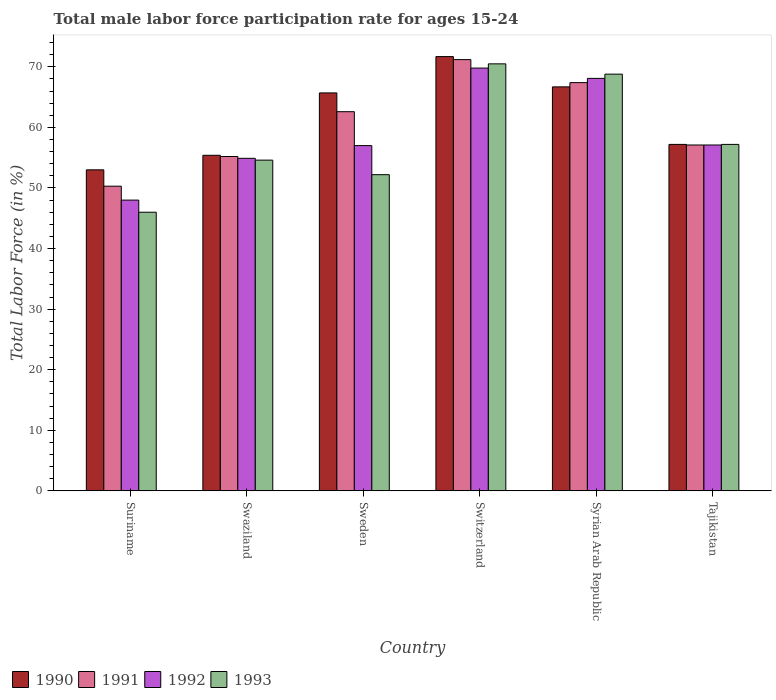How many groups of bars are there?
Offer a terse response. 6. Are the number of bars on each tick of the X-axis equal?
Make the answer very short. Yes. How many bars are there on the 5th tick from the left?
Give a very brief answer. 4. How many bars are there on the 3rd tick from the right?
Your response must be concise. 4. What is the label of the 2nd group of bars from the left?
Offer a terse response. Swaziland. What is the male labor force participation rate in 1993 in Switzerland?
Make the answer very short. 70.5. Across all countries, what is the maximum male labor force participation rate in 1993?
Your answer should be compact. 70.5. In which country was the male labor force participation rate in 1993 maximum?
Make the answer very short. Switzerland. In which country was the male labor force participation rate in 1992 minimum?
Your answer should be very brief. Suriname. What is the total male labor force participation rate in 1993 in the graph?
Give a very brief answer. 349.3. What is the difference between the male labor force participation rate in 1992 in Switzerland and that in Syrian Arab Republic?
Offer a very short reply. 1.7. What is the difference between the male labor force participation rate in 1990 in Sweden and the male labor force participation rate in 1993 in Syrian Arab Republic?
Your answer should be very brief. -3.1. What is the average male labor force participation rate in 1990 per country?
Provide a succinct answer. 61.62. What is the difference between the male labor force participation rate of/in 1993 and male labor force participation rate of/in 1992 in Sweden?
Provide a short and direct response. -4.8. What is the ratio of the male labor force participation rate in 1992 in Suriname to that in Tajikistan?
Your answer should be very brief. 0.84. What is the difference between the highest and the second highest male labor force participation rate in 1993?
Your response must be concise. -11.6. In how many countries, is the male labor force participation rate in 1993 greater than the average male labor force participation rate in 1993 taken over all countries?
Ensure brevity in your answer.  2. What does the 2nd bar from the left in Syrian Arab Republic represents?
Keep it short and to the point. 1991. Are all the bars in the graph horizontal?
Your answer should be very brief. No. What is the difference between two consecutive major ticks on the Y-axis?
Give a very brief answer. 10. Where does the legend appear in the graph?
Your answer should be compact. Bottom left. How many legend labels are there?
Give a very brief answer. 4. What is the title of the graph?
Keep it short and to the point. Total male labor force participation rate for ages 15-24. Does "1993" appear as one of the legend labels in the graph?
Make the answer very short. Yes. What is the Total Labor Force (in %) of 1991 in Suriname?
Ensure brevity in your answer.  50.3. What is the Total Labor Force (in %) of 1992 in Suriname?
Provide a succinct answer. 48. What is the Total Labor Force (in %) in 1993 in Suriname?
Give a very brief answer. 46. What is the Total Labor Force (in %) in 1990 in Swaziland?
Give a very brief answer. 55.4. What is the Total Labor Force (in %) of 1991 in Swaziland?
Give a very brief answer. 55.2. What is the Total Labor Force (in %) of 1992 in Swaziland?
Your answer should be very brief. 54.9. What is the Total Labor Force (in %) in 1993 in Swaziland?
Your answer should be compact. 54.6. What is the Total Labor Force (in %) of 1990 in Sweden?
Provide a short and direct response. 65.7. What is the Total Labor Force (in %) of 1991 in Sweden?
Provide a succinct answer. 62.6. What is the Total Labor Force (in %) of 1992 in Sweden?
Your response must be concise. 57. What is the Total Labor Force (in %) in 1993 in Sweden?
Keep it short and to the point. 52.2. What is the Total Labor Force (in %) of 1990 in Switzerland?
Your answer should be very brief. 71.7. What is the Total Labor Force (in %) in 1991 in Switzerland?
Offer a terse response. 71.2. What is the Total Labor Force (in %) in 1992 in Switzerland?
Keep it short and to the point. 69.8. What is the Total Labor Force (in %) in 1993 in Switzerland?
Provide a short and direct response. 70.5. What is the Total Labor Force (in %) of 1990 in Syrian Arab Republic?
Your response must be concise. 66.7. What is the Total Labor Force (in %) of 1991 in Syrian Arab Republic?
Your response must be concise. 67.4. What is the Total Labor Force (in %) of 1992 in Syrian Arab Republic?
Your answer should be very brief. 68.1. What is the Total Labor Force (in %) in 1993 in Syrian Arab Republic?
Give a very brief answer. 68.8. What is the Total Labor Force (in %) in 1990 in Tajikistan?
Provide a short and direct response. 57.2. What is the Total Labor Force (in %) of 1991 in Tajikistan?
Provide a short and direct response. 57.1. What is the Total Labor Force (in %) in 1992 in Tajikistan?
Ensure brevity in your answer.  57.1. What is the Total Labor Force (in %) of 1993 in Tajikistan?
Give a very brief answer. 57.2. Across all countries, what is the maximum Total Labor Force (in %) in 1990?
Keep it short and to the point. 71.7. Across all countries, what is the maximum Total Labor Force (in %) in 1991?
Ensure brevity in your answer.  71.2. Across all countries, what is the maximum Total Labor Force (in %) of 1992?
Your answer should be very brief. 69.8. Across all countries, what is the maximum Total Labor Force (in %) of 1993?
Provide a short and direct response. 70.5. Across all countries, what is the minimum Total Labor Force (in %) in 1990?
Make the answer very short. 53. Across all countries, what is the minimum Total Labor Force (in %) of 1991?
Ensure brevity in your answer.  50.3. What is the total Total Labor Force (in %) in 1990 in the graph?
Give a very brief answer. 369.7. What is the total Total Labor Force (in %) in 1991 in the graph?
Ensure brevity in your answer.  363.8. What is the total Total Labor Force (in %) in 1992 in the graph?
Your answer should be very brief. 354.9. What is the total Total Labor Force (in %) in 1993 in the graph?
Offer a terse response. 349.3. What is the difference between the Total Labor Force (in %) of 1991 in Suriname and that in Swaziland?
Provide a succinct answer. -4.9. What is the difference between the Total Labor Force (in %) of 1990 in Suriname and that in Sweden?
Keep it short and to the point. -12.7. What is the difference between the Total Labor Force (in %) in 1992 in Suriname and that in Sweden?
Provide a succinct answer. -9. What is the difference between the Total Labor Force (in %) in 1993 in Suriname and that in Sweden?
Make the answer very short. -6.2. What is the difference between the Total Labor Force (in %) in 1990 in Suriname and that in Switzerland?
Your answer should be compact. -18.7. What is the difference between the Total Labor Force (in %) in 1991 in Suriname and that in Switzerland?
Offer a very short reply. -20.9. What is the difference between the Total Labor Force (in %) of 1992 in Suriname and that in Switzerland?
Offer a very short reply. -21.8. What is the difference between the Total Labor Force (in %) in 1993 in Suriname and that in Switzerland?
Your response must be concise. -24.5. What is the difference between the Total Labor Force (in %) in 1990 in Suriname and that in Syrian Arab Republic?
Provide a succinct answer. -13.7. What is the difference between the Total Labor Force (in %) in 1991 in Suriname and that in Syrian Arab Republic?
Your answer should be compact. -17.1. What is the difference between the Total Labor Force (in %) of 1992 in Suriname and that in Syrian Arab Republic?
Keep it short and to the point. -20.1. What is the difference between the Total Labor Force (in %) in 1993 in Suriname and that in Syrian Arab Republic?
Your response must be concise. -22.8. What is the difference between the Total Labor Force (in %) in 1991 in Suriname and that in Tajikistan?
Offer a terse response. -6.8. What is the difference between the Total Labor Force (in %) in 1993 in Suriname and that in Tajikistan?
Provide a succinct answer. -11.2. What is the difference between the Total Labor Force (in %) in 1990 in Swaziland and that in Sweden?
Provide a short and direct response. -10.3. What is the difference between the Total Labor Force (in %) of 1992 in Swaziland and that in Sweden?
Offer a very short reply. -2.1. What is the difference between the Total Labor Force (in %) of 1993 in Swaziland and that in Sweden?
Give a very brief answer. 2.4. What is the difference between the Total Labor Force (in %) of 1990 in Swaziland and that in Switzerland?
Provide a short and direct response. -16.3. What is the difference between the Total Labor Force (in %) of 1992 in Swaziland and that in Switzerland?
Give a very brief answer. -14.9. What is the difference between the Total Labor Force (in %) in 1993 in Swaziland and that in Switzerland?
Your answer should be very brief. -15.9. What is the difference between the Total Labor Force (in %) of 1991 in Swaziland and that in Syrian Arab Republic?
Provide a succinct answer. -12.2. What is the difference between the Total Labor Force (in %) of 1992 in Swaziland and that in Syrian Arab Republic?
Offer a terse response. -13.2. What is the difference between the Total Labor Force (in %) of 1990 in Swaziland and that in Tajikistan?
Give a very brief answer. -1.8. What is the difference between the Total Labor Force (in %) in 1993 in Swaziland and that in Tajikistan?
Offer a terse response. -2.6. What is the difference between the Total Labor Force (in %) in 1991 in Sweden and that in Switzerland?
Make the answer very short. -8.6. What is the difference between the Total Labor Force (in %) of 1992 in Sweden and that in Switzerland?
Your answer should be very brief. -12.8. What is the difference between the Total Labor Force (in %) in 1993 in Sweden and that in Switzerland?
Keep it short and to the point. -18.3. What is the difference between the Total Labor Force (in %) in 1990 in Sweden and that in Syrian Arab Republic?
Offer a terse response. -1. What is the difference between the Total Labor Force (in %) in 1991 in Sweden and that in Syrian Arab Republic?
Your answer should be very brief. -4.8. What is the difference between the Total Labor Force (in %) of 1993 in Sweden and that in Syrian Arab Republic?
Provide a succinct answer. -16.6. What is the difference between the Total Labor Force (in %) of 1991 in Sweden and that in Tajikistan?
Keep it short and to the point. 5.5. What is the difference between the Total Labor Force (in %) in 1992 in Sweden and that in Tajikistan?
Offer a terse response. -0.1. What is the difference between the Total Labor Force (in %) of 1990 in Switzerland and that in Syrian Arab Republic?
Your answer should be very brief. 5. What is the difference between the Total Labor Force (in %) of 1992 in Switzerland and that in Syrian Arab Republic?
Offer a very short reply. 1.7. What is the difference between the Total Labor Force (in %) of 1991 in Switzerland and that in Tajikistan?
Ensure brevity in your answer.  14.1. What is the difference between the Total Labor Force (in %) in 1993 in Switzerland and that in Tajikistan?
Provide a short and direct response. 13.3. What is the difference between the Total Labor Force (in %) of 1990 in Syrian Arab Republic and that in Tajikistan?
Offer a very short reply. 9.5. What is the difference between the Total Labor Force (in %) of 1991 in Syrian Arab Republic and that in Tajikistan?
Offer a terse response. 10.3. What is the difference between the Total Labor Force (in %) in 1992 in Syrian Arab Republic and that in Tajikistan?
Ensure brevity in your answer.  11. What is the difference between the Total Labor Force (in %) of 1993 in Syrian Arab Republic and that in Tajikistan?
Offer a very short reply. 11.6. What is the difference between the Total Labor Force (in %) of 1990 in Suriname and the Total Labor Force (in %) of 1991 in Swaziland?
Your answer should be very brief. -2.2. What is the difference between the Total Labor Force (in %) of 1990 in Suriname and the Total Labor Force (in %) of 1992 in Swaziland?
Ensure brevity in your answer.  -1.9. What is the difference between the Total Labor Force (in %) of 1990 in Suriname and the Total Labor Force (in %) of 1993 in Swaziland?
Offer a terse response. -1.6. What is the difference between the Total Labor Force (in %) of 1991 in Suriname and the Total Labor Force (in %) of 1993 in Swaziland?
Give a very brief answer. -4.3. What is the difference between the Total Labor Force (in %) in 1992 in Suriname and the Total Labor Force (in %) in 1993 in Swaziland?
Ensure brevity in your answer.  -6.6. What is the difference between the Total Labor Force (in %) of 1990 in Suriname and the Total Labor Force (in %) of 1992 in Sweden?
Give a very brief answer. -4. What is the difference between the Total Labor Force (in %) in 1990 in Suriname and the Total Labor Force (in %) in 1993 in Sweden?
Provide a short and direct response. 0.8. What is the difference between the Total Labor Force (in %) in 1991 in Suriname and the Total Labor Force (in %) in 1992 in Sweden?
Offer a very short reply. -6.7. What is the difference between the Total Labor Force (in %) in 1990 in Suriname and the Total Labor Force (in %) in 1991 in Switzerland?
Offer a terse response. -18.2. What is the difference between the Total Labor Force (in %) of 1990 in Suriname and the Total Labor Force (in %) of 1992 in Switzerland?
Make the answer very short. -16.8. What is the difference between the Total Labor Force (in %) of 1990 in Suriname and the Total Labor Force (in %) of 1993 in Switzerland?
Your response must be concise. -17.5. What is the difference between the Total Labor Force (in %) in 1991 in Suriname and the Total Labor Force (in %) in 1992 in Switzerland?
Offer a terse response. -19.5. What is the difference between the Total Labor Force (in %) in 1991 in Suriname and the Total Labor Force (in %) in 1993 in Switzerland?
Your answer should be very brief. -20.2. What is the difference between the Total Labor Force (in %) of 1992 in Suriname and the Total Labor Force (in %) of 1993 in Switzerland?
Keep it short and to the point. -22.5. What is the difference between the Total Labor Force (in %) of 1990 in Suriname and the Total Labor Force (in %) of 1991 in Syrian Arab Republic?
Ensure brevity in your answer.  -14.4. What is the difference between the Total Labor Force (in %) of 1990 in Suriname and the Total Labor Force (in %) of 1992 in Syrian Arab Republic?
Your answer should be very brief. -15.1. What is the difference between the Total Labor Force (in %) of 1990 in Suriname and the Total Labor Force (in %) of 1993 in Syrian Arab Republic?
Keep it short and to the point. -15.8. What is the difference between the Total Labor Force (in %) in 1991 in Suriname and the Total Labor Force (in %) in 1992 in Syrian Arab Republic?
Give a very brief answer. -17.8. What is the difference between the Total Labor Force (in %) of 1991 in Suriname and the Total Labor Force (in %) of 1993 in Syrian Arab Republic?
Your answer should be compact. -18.5. What is the difference between the Total Labor Force (in %) in 1992 in Suriname and the Total Labor Force (in %) in 1993 in Syrian Arab Republic?
Make the answer very short. -20.8. What is the difference between the Total Labor Force (in %) in 1990 in Suriname and the Total Labor Force (in %) in 1992 in Tajikistan?
Offer a very short reply. -4.1. What is the difference between the Total Labor Force (in %) in 1990 in Suriname and the Total Labor Force (in %) in 1993 in Tajikistan?
Provide a short and direct response. -4.2. What is the difference between the Total Labor Force (in %) of 1992 in Suriname and the Total Labor Force (in %) of 1993 in Tajikistan?
Ensure brevity in your answer.  -9.2. What is the difference between the Total Labor Force (in %) in 1991 in Swaziland and the Total Labor Force (in %) in 1993 in Sweden?
Your response must be concise. 3. What is the difference between the Total Labor Force (in %) of 1990 in Swaziland and the Total Labor Force (in %) of 1991 in Switzerland?
Ensure brevity in your answer.  -15.8. What is the difference between the Total Labor Force (in %) in 1990 in Swaziland and the Total Labor Force (in %) in 1992 in Switzerland?
Ensure brevity in your answer.  -14.4. What is the difference between the Total Labor Force (in %) in 1990 in Swaziland and the Total Labor Force (in %) in 1993 in Switzerland?
Provide a short and direct response. -15.1. What is the difference between the Total Labor Force (in %) in 1991 in Swaziland and the Total Labor Force (in %) in 1992 in Switzerland?
Offer a very short reply. -14.6. What is the difference between the Total Labor Force (in %) in 1991 in Swaziland and the Total Labor Force (in %) in 1993 in Switzerland?
Ensure brevity in your answer.  -15.3. What is the difference between the Total Labor Force (in %) of 1992 in Swaziland and the Total Labor Force (in %) of 1993 in Switzerland?
Provide a succinct answer. -15.6. What is the difference between the Total Labor Force (in %) of 1990 in Swaziland and the Total Labor Force (in %) of 1993 in Syrian Arab Republic?
Make the answer very short. -13.4. What is the difference between the Total Labor Force (in %) of 1992 in Swaziland and the Total Labor Force (in %) of 1993 in Syrian Arab Republic?
Make the answer very short. -13.9. What is the difference between the Total Labor Force (in %) of 1990 in Swaziland and the Total Labor Force (in %) of 1992 in Tajikistan?
Ensure brevity in your answer.  -1.7. What is the difference between the Total Labor Force (in %) in 1991 in Swaziland and the Total Labor Force (in %) in 1992 in Tajikistan?
Make the answer very short. -1.9. What is the difference between the Total Labor Force (in %) of 1992 in Swaziland and the Total Labor Force (in %) of 1993 in Tajikistan?
Your answer should be compact. -2.3. What is the difference between the Total Labor Force (in %) of 1990 in Sweden and the Total Labor Force (in %) of 1991 in Switzerland?
Keep it short and to the point. -5.5. What is the difference between the Total Labor Force (in %) in 1990 in Sweden and the Total Labor Force (in %) in 1992 in Switzerland?
Ensure brevity in your answer.  -4.1. What is the difference between the Total Labor Force (in %) of 1991 in Sweden and the Total Labor Force (in %) of 1993 in Switzerland?
Ensure brevity in your answer.  -7.9. What is the difference between the Total Labor Force (in %) in 1990 in Sweden and the Total Labor Force (in %) in 1991 in Syrian Arab Republic?
Your response must be concise. -1.7. What is the difference between the Total Labor Force (in %) of 1990 in Sweden and the Total Labor Force (in %) of 1992 in Syrian Arab Republic?
Provide a succinct answer. -2.4. What is the difference between the Total Labor Force (in %) in 1990 in Sweden and the Total Labor Force (in %) in 1993 in Syrian Arab Republic?
Give a very brief answer. -3.1. What is the difference between the Total Labor Force (in %) of 1991 in Sweden and the Total Labor Force (in %) of 1992 in Syrian Arab Republic?
Keep it short and to the point. -5.5. What is the difference between the Total Labor Force (in %) of 1991 in Sweden and the Total Labor Force (in %) of 1992 in Tajikistan?
Your response must be concise. 5.5. What is the difference between the Total Labor Force (in %) in 1991 in Sweden and the Total Labor Force (in %) in 1993 in Tajikistan?
Provide a short and direct response. 5.4. What is the difference between the Total Labor Force (in %) of 1990 in Switzerland and the Total Labor Force (in %) of 1992 in Syrian Arab Republic?
Keep it short and to the point. 3.6. What is the difference between the Total Labor Force (in %) in 1991 in Switzerland and the Total Labor Force (in %) in 1993 in Syrian Arab Republic?
Offer a very short reply. 2.4. What is the difference between the Total Labor Force (in %) of 1990 in Switzerland and the Total Labor Force (in %) of 1992 in Tajikistan?
Your response must be concise. 14.6. What is the difference between the Total Labor Force (in %) in 1991 in Switzerland and the Total Labor Force (in %) in 1992 in Tajikistan?
Ensure brevity in your answer.  14.1. What is the difference between the Total Labor Force (in %) of 1991 in Syrian Arab Republic and the Total Labor Force (in %) of 1992 in Tajikistan?
Offer a terse response. 10.3. What is the difference between the Total Labor Force (in %) in 1992 in Syrian Arab Republic and the Total Labor Force (in %) in 1993 in Tajikistan?
Offer a terse response. 10.9. What is the average Total Labor Force (in %) in 1990 per country?
Make the answer very short. 61.62. What is the average Total Labor Force (in %) in 1991 per country?
Make the answer very short. 60.63. What is the average Total Labor Force (in %) of 1992 per country?
Provide a succinct answer. 59.15. What is the average Total Labor Force (in %) of 1993 per country?
Provide a succinct answer. 58.22. What is the difference between the Total Labor Force (in %) of 1990 and Total Labor Force (in %) of 1992 in Suriname?
Your answer should be compact. 5. What is the difference between the Total Labor Force (in %) in 1991 and Total Labor Force (in %) in 1993 in Suriname?
Ensure brevity in your answer.  4.3. What is the difference between the Total Labor Force (in %) of 1992 and Total Labor Force (in %) of 1993 in Suriname?
Your answer should be very brief. 2. What is the difference between the Total Labor Force (in %) in 1990 and Total Labor Force (in %) in 1991 in Swaziland?
Give a very brief answer. 0.2. What is the difference between the Total Labor Force (in %) of 1990 and Total Labor Force (in %) of 1992 in Swaziland?
Provide a short and direct response. 0.5. What is the difference between the Total Labor Force (in %) of 1991 and Total Labor Force (in %) of 1992 in Sweden?
Provide a succinct answer. 5.6. What is the difference between the Total Labor Force (in %) in 1991 and Total Labor Force (in %) in 1993 in Sweden?
Keep it short and to the point. 10.4. What is the difference between the Total Labor Force (in %) of 1990 and Total Labor Force (in %) of 1991 in Switzerland?
Offer a very short reply. 0.5. What is the difference between the Total Labor Force (in %) in 1990 and Total Labor Force (in %) in 1992 in Switzerland?
Offer a terse response. 1.9. What is the difference between the Total Labor Force (in %) of 1990 and Total Labor Force (in %) of 1993 in Switzerland?
Offer a very short reply. 1.2. What is the difference between the Total Labor Force (in %) of 1991 and Total Labor Force (in %) of 1992 in Switzerland?
Ensure brevity in your answer.  1.4. What is the difference between the Total Labor Force (in %) in 1991 and Total Labor Force (in %) in 1993 in Switzerland?
Provide a short and direct response. 0.7. What is the difference between the Total Labor Force (in %) in 1992 and Total Labor Force (in %) in 1993 in Switzerland?
Make the answer very short. -0.7. What is the difference between the Total Labor Force (in %) of 1990 and Total Labor Force (in %) of 1991 in Syrian Arab Republic?
Provide a succinct answer. -0.7. What is the difference between the Total Labor Force (in %) in 1990 and Total Labor Force (in %) in 1993 in Syrian Arab Republic?
Give a very brief answer. -2.1. What is the difference between the Total Labor Force (in %) of 1991 and Total Labor Force (in %) of 1992 in Syrian Arab Republic?
Offer a very short reply. -0.7. What is the difference between the Total Labor Force (in %) of 1990 and Total Labor Force (in %) of 1991 in Tajikistan?
Give a very brief answer. 0.1. What is the difference between the Total Labor Force (in %) in 1990 and Total Labor Force (in %) in 1993 in Tajikistan?
Offer a very short reply. 0. What is the difference between the Total Labor Force (in %) in 1991 and Total Labor Force (in %) in 1992 in Tajikistan?
Keep it short and to the point. 0. What is the ratio of the Total Labor Force (in %) in 1990 in Suriname to that in Swaziland?
Offer a terse response. 0.96. What is the ratio of the Total Labor Force (in %) in 1991 in Suriname to that in Swaziland?
Make the answer very short. 0.91. What is the ratio of the Total Labor Force (in %) of 1992 in Suriname to that in Swaziland?
Your answer should be very brief. 0.87. What is the ratio of the Total Labor Force (in %) in 1993 in Suriname to that in Swaziland?
Make the answer very short. 0.84. What is the ratio of the Total Labor Force (in %) in 1990 in Suriname to that in Sweden?
Offer a very short reply. 0.81. What is the ratio of the Total Labor Force (in %) in 1991 in Suriname to that in Sweden?
Give a very brief answer. 0.8. What is the ratio of the Total Labor Force (in %) of 1992 in Suriname to that in Sweden?
Your answer should be very brief. 0.84. What is the ratio of the Total Labor Force (in %) of 1993 in Suriname to that in Sweden?
Make the answer very short. 0.88. What is the ratio of the Total Labor Force (in %) in 1990 in Suriname to that in Switzerland?
Your answer should be compact. 0.74. What is the ratio of the Total Labor Force (in %) of 1991 in Suriname to that in Switzerland?
Make the answer very short. 0.71. What is the ratio of the Total Labor Force (in %) of 1992 in Suriname to that in Switzerland?
Give a very brief answer. 0.69. What is the ratio of the Total Labor Force (in %) of 1993 in Suriname to that in Switzerland?
Keep it short and to the point. 0.65. What is the ratio of the Total Labor Force (in %) of 1990 in Suriname to that in Syrian Arab Republic?
Provide a short and direct response. 0.79. What is the ratio of the Total Labor Force (in %) of 1991 in Suriname to that in Syrian Arab Republic?
Offer a very short reply. 0.75. What is the ratio of the Total Labor Force (in %) of 1992 in Suriname to that in Syrian Arab Republic?
Your response must be concise. 0.7. What is the ratio of the Total Labor Force (in %) of 1993 in Suriname to that in Syrian Arab Republic?
Make the answer very short. 0.67. What is the ratio of the Total Labor Force (in %) of 1990 in Suriname to that in Tajikistan?
Provide a succinct answer. 0.93. What is the ratio of the Total Labor Force (in %) in 1991 in Suriname to that in Tajikistan?
Keep it short and to the point. 0.88. What is the ratio of the Total Labor Force (in %) in 1992 in Suriname to that in Tajikistan?
Keep it short and to the point. 0.84. What is the ratio of the Total Labor Force (in %) in 1993 in Suriname to that in Tajikistan?
Your answer should be compact. 0.8. What is the ratio of the Total Labor Force (in %) of 1990 in Swaziland to that in Sweden?
Your response must be concise. 0.84. What is the ratio of the Total Labor Force (in %) in 1991 in Swaziland to that in Sweden?
Offer a very short reply. 0.88. What is the ratio of the Total Labor Force (in %) in 1992 in Swaziland to that in Sweden?
Offer a terse response. 0.96. What is the ratio of the Total Labor Force (in %) in 1993 in Swaziland to that in Sweden?
Your response must be concise. 1.05. What is the ratio of the Total Labor Force (in %) of 1990 in Swaziland to that in Switzerland?
Offer a very short reply. 0.77. What is the ratio of the Total Labor Force (in %) in 1991 in Swaziland to that in Switzerland?
Your answer should be very brief. 0.78. What is the ratio of the Total Labor Force (in %) of 1992 in Swaziland to that in Switzerland?
Give a very brief answer. 0.79. What is the ratio of the Total Labor Force (in %) in 1993 in Swaziland to that in Switzerland?
Offer a very short reply. 0.77. What is the ratio of the Total Labor Force (in %) in 1990 in Swaziland to that in Syrian Arab Republic?
Offer a terse response. 0.83. What is the ratio of the Total Labor Force (in %) of 1991 in Swaziland to that in Syrian Arab Republic?
Provide a short and direct response. 0.82. What is the ratio of the Total Labor Force (in %) of 1992 in Swaziland to that in Syrian Arab Republic?
Offer a terse response. 0.81. What is the ratio of the Total Labor Force (in %) in 1993 in Swaziland to that in Syrian Arab Republic?
Provide a short and direct response. 0.79. What is the ratio of the Total Labor Force (in %) in 1990 in Swaziland to that in Tajikistan?
Ensure brevity in your answer.  0.97. What is the ratio of the Total Labor Force (in %) in 1991 in Swaziland to that in Tajikistan?
Ensure brevity in your answer.  0.97. What is the ratio of the Total Labor Force (in %) of 1992 in Swaziland to that in Tajikistan?
Offer a very short reply. 0.96. What is the ratio of the Total Labor Force (in %) of 1993 in Swaziland to that in Tajikistan?
Your answer should be very brief. 0.95. What is the ratio of the Total Labor Force (in %) of 1990 in Sweden to that in Switzerland?
Give a very brief answer. 0.92. What is the ratio of the Total Labor Force (in %) of 1991 in Sweden to that in Switzerland?
Your answer should be very brief. 0.88. What is the ratio of the Total Labor Force (in %) in 1992 in Sweden to that in Switzerland?
Provide a succinct answer. 0.82. What is the ratio of the Total Labor Force (in %) of 1993 in Sweden to that in Switzerland?
Your answer should be very brief. 0.74. What is the ratio of the Total Labor Force (in %) of 1991 in Sweden to that in Syrian Arab Republic?
Provide a succinct answer. 0.93. What is the ratio of the Total Labor Force (in %) of 1992 in Sweden to that in Syrian Arab Republic?
Provide a short and direct response. 0.84. What is the ratio of the Total Labor Force (in %) in 1993 in Sweden to that in Syrian Arab Republic?
Your answer should be very brief. 0.76. What is the ratio of the Total Labor Force (in %) of 1990 in Sweden to that in Tajikistan?
Provide a succinct answer. 1.15. What is the ratio of the Total Labor Force (in %) in 1991 in Sweden to that in Tajikistan?
Offer a terse response. 1.1. What is the ratio of the Total Labor Force (in %) of 1992 in Sweden to that in Tajikistan?
Make the answer very short. 1. What is the ratio of the Total Labor Force (in %) of 1993 in Sweden to that in Tajikistan?
Provide a succinct answer. 0.91. What is the ratio of the Total Labor Force (in %) of 1990 in Switzerland to that in Syrian Arab Republic?
Provide a short and direct response. 1.07. What is the ratio of the Total Labor Force (in %) in 1991 in Switzerland to that in Syrian Arab Republic?
Your response must be concise. 1.06. What is the ratio of the Total Labor Force (in %) in 1993 in Switzerland to that in Syrian Arab Republic?
Your response must be concise. 1.02. What is the ratio of the Total Labor Force (in %) of 1990 in Switzerland to that in Tajikistan?
Make the answer very short. 1.25. What is the ratio of the Total Labor Force (in %) of 1991 in Switzerland to that in Tajikistan?
Your response must be concise. 1.25. What is the ratio of the Total Labor Force (in %) of 1992 in Switzerland to that in Tajikistan?
Offer a terse response. 1.22. What is the ratio of the Total Labor Force (in %) of 1993 in Switzerland to that in Tajikistan?
Offer a very short reply. 1.23. What is the ratio of the Total Labor Force (in %) of 1990 in Syrian Arab Republic to that in Tajikistan?
Your answer should be compact. 1.17. What is the ratio of the Total Labor Force (in %) in 1991 in Syrian Arab Republic to that in Tajikistan?
Your answer should be compact. 1.18. What is the ratio of the Total Labor Force (in %) in 1992 in Syrian Arab Republic to that in Tajikistan?
Provide a succinct answer. 1.19. What is the ratio of the Total Labor Force (in %) of 1993 in Syrian Arab Republic to that in Tajikistan?
Offer a terse response. 1.2. What is the difference between the highest and the second highest Total Labor Force (in %) in 1990?
Provide a short and direct response. 5. What is the difference between the highest and the second highest Total Labor Force (in %) in 1993?
Provide a succinct answer. 1.7. What is the difference between the highest and the lowest Total Labor Force (in %) in 1991?
Provide a short and direct response. 20.9. What is the difference between the highest and the lowest Total Labor Force (in %) in 1992?
Ensure brevity in your answer.  21.8. What is the difference between the highest and the lowest Total Labor Force (in %) of 1993?
Your response must be concise. 24.5. 